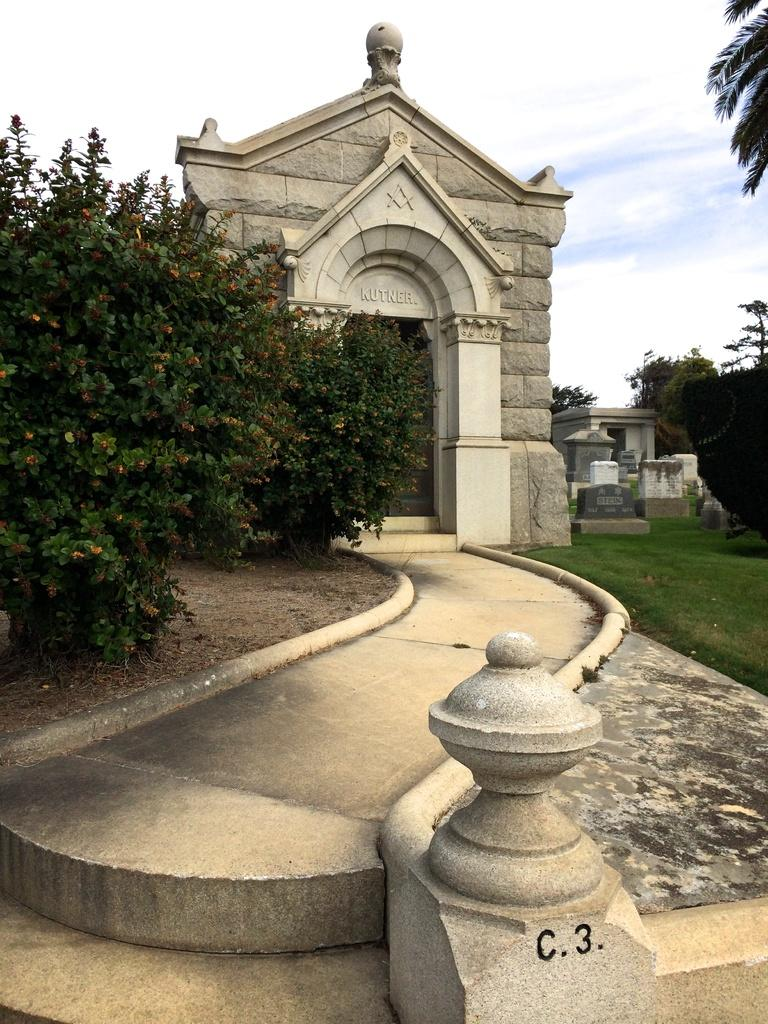What type of path is visible in the image? There is a walkway in the image. What structure can be seen above the walkway? There is an arch in the image. What type of vegetation is present in the image? There is grass in the image. What can be seen in the background of the image? There are trees and stones in the background of the image. What type of van is parked near the arch in the image? There is no van present in the image; it only features a walkway, an arch, grass, trees, and stones. Can you spot a rabbit hopping around the trees in the image? There is no rabbit present in the image. 